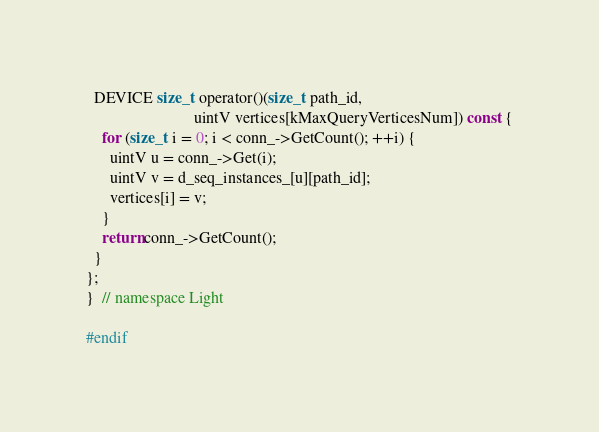<code> <loc_0><loc_0><loc_500><loc_500><_Cuda_>  DEVICE size_t operator()(size_t path_id,
                           uintV vertices[kMaxQueryVerticesNum]) const {
    for (size_t i = 0; i < conn_->GetCount(); ++i) {
      uintV u = conn_->Get(i);
      uintV v = d_seq_instances_[u][path_id];
      vertices[i] = v;
    }
    return conn_->GetCount();
  }
};
}  // namespace Light

#endif</code> 